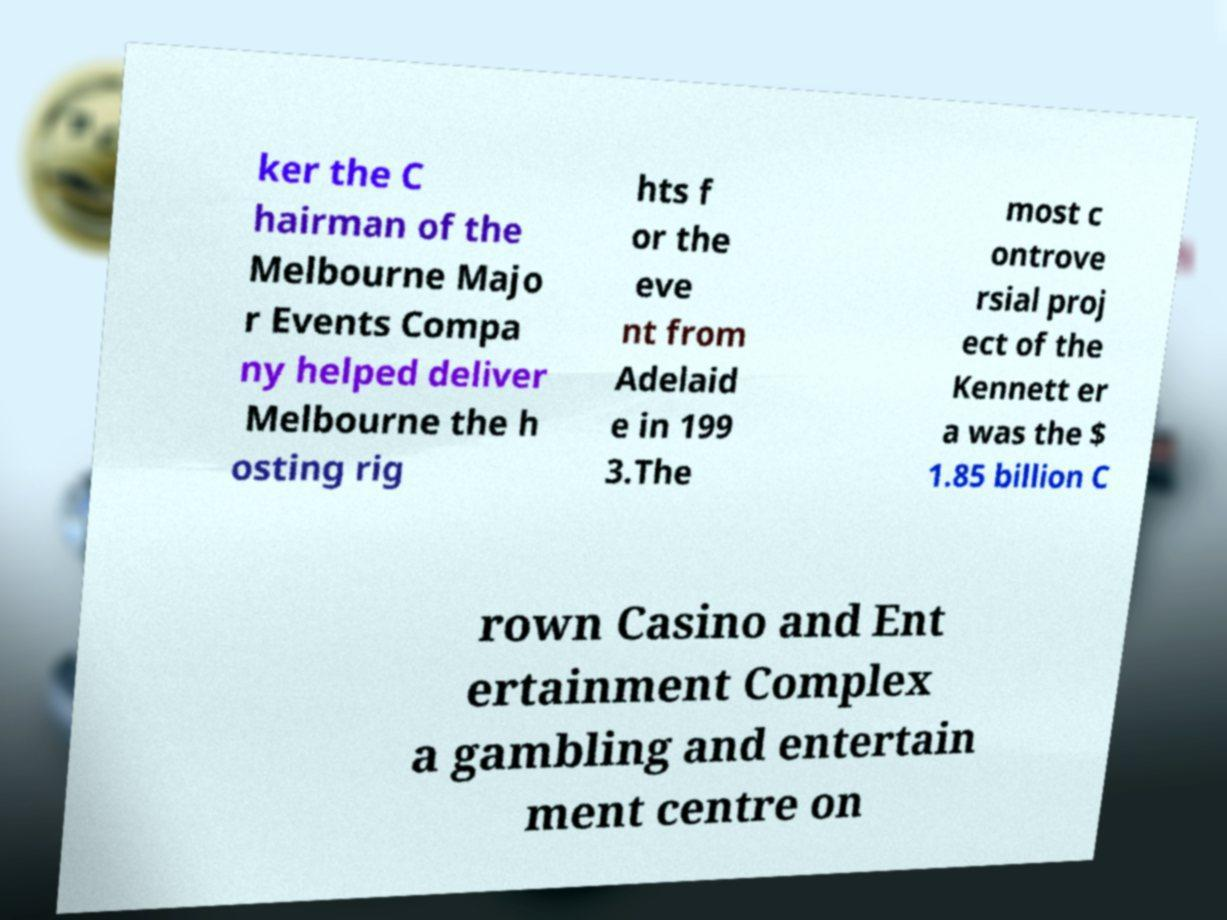Can you read and provide the text displayed in the image?This photo seems to have some interesting text. Can you extract and type it out for me? ker the C hairman of the Melbourne Majo r Events Compa ny helped deliver Melbourne the h osting rig hts f or the eve nt from Adelaid e in 199 3.The most c ontrove rsial proj ect of the Kennett er a was the $ 1.85 billion C rown Casino and Ent ertainment Complex a gambling and entertain ment centre on 